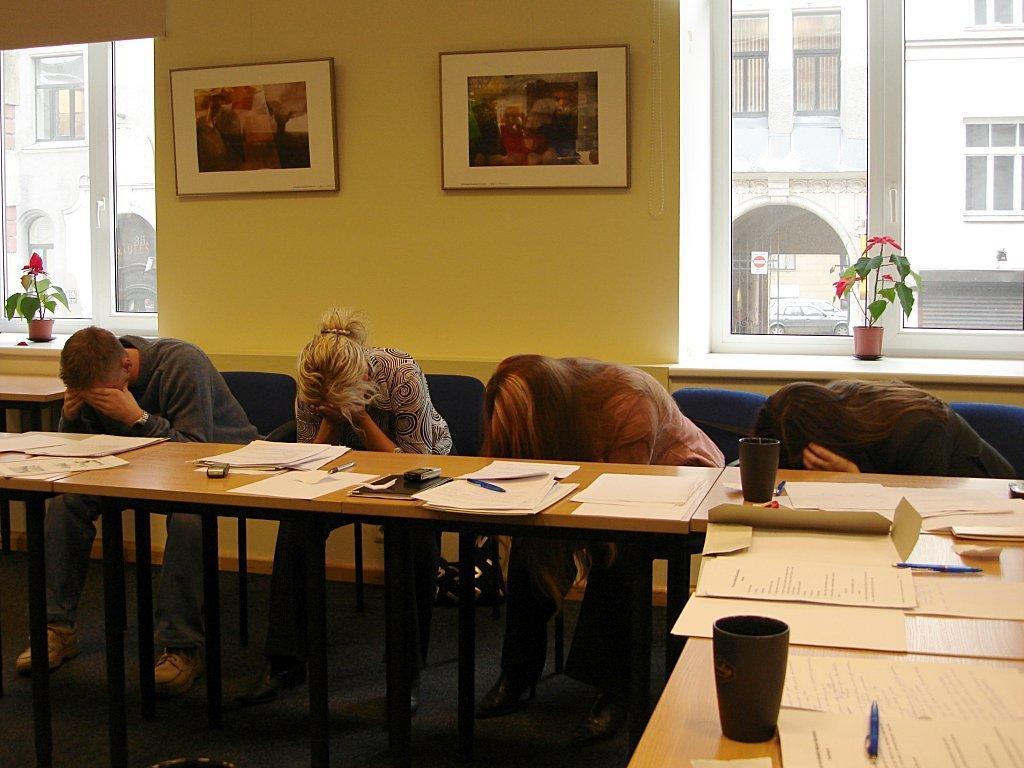Describe this image in one or two sentences. There are four people who are laying their heads down, there is a table in front of them and there are lot of papers and pens, there are two black color cups on the table, behind these people there are two photo frames attached to the wall which is of cream color and there are two windows on the either side and there are plants in front of the window, in the background there is a building. 